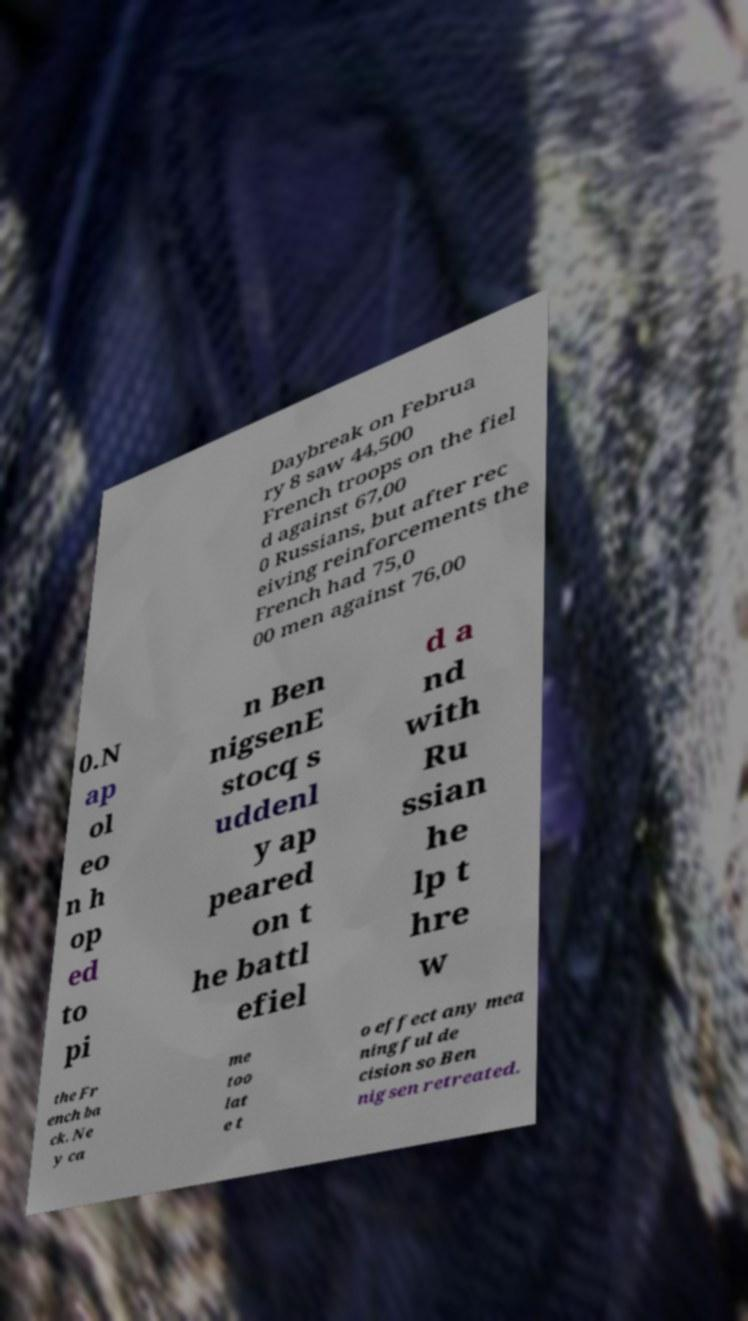What messages or text are displayed in this image? I need them in a readable, typed format. Daybreak on Februa ry 8 saw 44,500 French troops on the fiel d against 67,00 0 Russians, but after rec eiving reinforcements the French had 75,0 00 men against 76,00 0.N ap ol eo n h op ed to pi n Ben nigsenE stocq s uddenl y ap peared on t he battl efiel d a nd with Ru ssian he lp t hre w the Fr ench ba ck. Ne y ca me too lat e t o effect any mea ningful de cision so Ben nigsen retreated. 